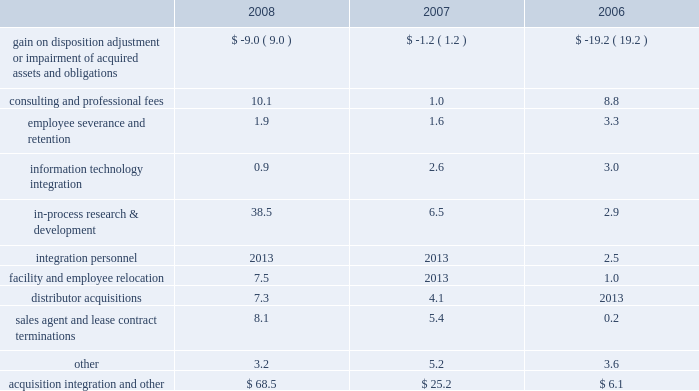December 31 , 2008 , 2007 and 2006 , included ( in millions ) : .
Included in the gain on disposition , adjustment or impairment of acquired assets and obligations for 2008 is a favorable adjustment to certain liabilities of acquired companies due to changes in circumstances surrounding those liabilities subsequent to the related measurement period .
Included in the gain on disposition , adjustment or impairment of acquired assets and obligations for 2006 is the sale of the former centerpulse austin land and facilities for a gain of $ 5.1 million and the favorable settlement of two pre- acquisition contingent liabilities .
These gains were offset by a $ 13.4 million impairment charge for certain centerpulse tradename and trademark intangibles based principally in our europe operating segment .
In-process research and development charges for 2008 are related to the acquisition of abbott spine .
In-process research and development charges for 2007 are related to the acquisitions of endius and orthosoft .
Consulting and professional fees relate to third- party integration consulting performed in a variety of areas such as tax , compliance , logistics and human resources and legal fees related to matters involving acquired businesses .
Cash and equivalents 2013 we consider all highly liquid investments with an original maturity of three months or less to be cash equivalents .
The carrying amounts reported in the balance sheet for cash and equivalents are valued at cost , which approximates their fair value .
Restricted cash is primarily composed of cash held in escrow related to certain insurance coverage .
Inventories 2013 inventories , net of allowances for obsolete and slow-moving goods , are stated at the lower of cost or market , with cost determined on a first-in first-out basis .
Property , plant and equipment 2013 property , plant and equipment is carried at cost less accumulated depreciation .
Depreciation is computed using the straight-line method based on estimated useful lives of ten to forty years for buildings and improvements , three to eight years for machinery and equipment .
Maintenance and repairs are expensed as incurred .
In accordance with statement of financial accounting standards ( 201csfas 201d ) no .
144 , 201caccounting for the impairment or disposal of long-lived assets , 201d we review property , plant and equipment for impairment whenever events or changes in circumstances indicate that the carrying value of an asset may not be recoverable .
An impairment loss would be recognized when estimated future undiscounted cash flows relating to the asset are less than its carrying amount .
An impairment loss is measured as the amount by which the carrying amount of an asset exceeds its fair value .
Software costs 2013 we capitalize certain computer software and software development costs incurred in connection with developing or obtaining computer software for internal use when both the preliminary project stage is completed and it is probable that the software will be used as intended .
Capitalized software costs generally include external direct costs of materials and services utilized in developing or obtaining computer software and compensation and related benefits for employees who are directly associated with the software project .
Capitalized software costs are included in property , plant and equipment on our balance sheet and amortized on a straight-line basis when the software is ready for its intended use over the estimated useful lives of the software , which approximate three to seven years .
Instruments 2013 instruments are hand-held devices used by orthopaedic surgeons during total joint replacement and other surgical procedures .
Instruments are recognized as long-lived assets and are included in property , plant and equipment .
Undeployed instruments are carried at cost , net of allowances for excess and obsolete instruments .
Instruments in the field are carried at cost less accumulated depreciation .
Depreciation is computed using the straight-line method based on average estimated useful lives , determined principally in reference to associated product life cycles , primarily five years .
We review instruments for impairment in accordance with sfas no .
144 .
Depreciation of instruments is recognized as selling , general and administrative expense .
Goodwill 2013 we account for goodwill in accordance with sfas no .
142 , 201cgoodwill and other intangible assets . 201d goodwill is not amortized but is subject to annual impairment tests .
Goodwill has been assigned to reporting units .
We perform annual impairment tests by comparing each reporting unit 2019s fair value to its carrying amount to determine if there is potential impairment .
The fair value of the reporting unit and the implied fair value of goodwill are determined based upon a discounted cash flow analysis .
Significant assumptions are incorporated into to these discounted cash flow analyses such as estimated growth rates and risk-adjusted discount rates .
We perform this test in the fourth quarter of the year .
If the fair value of the reporting unit is less than its carrying value , an impairment loss is recorded to the extent that the implied fair value of the reporting unit goodwill is less than the carrying value of the reporting unit goodwill .
Intangible assets 2013 we account for intangible assets in accordance with sfas no .
142 .
Intangible assets are initially measured at their fair value .
We have determined the fair value of our intangible assets either by the fair value of the z i m m e r h o l d i n g s , i n c .
2 0 0 8 f o r m 1 0 - k a n n u a l r e p o r t notes to consolidated financial statements ( continued ) %%transmsg*** transmitting job : c48761 pcn : 044000000 ***%%pcmsg|44 |00007|yes|no|02/24/2009 06:10|0|0|page is valid , no graphics -- color : d| .
What is the percent change in information technology integration from 2006 to 2007? 
Computations: ((3.0 - 2.6) / 2.6)
Answer: 0.15385. 